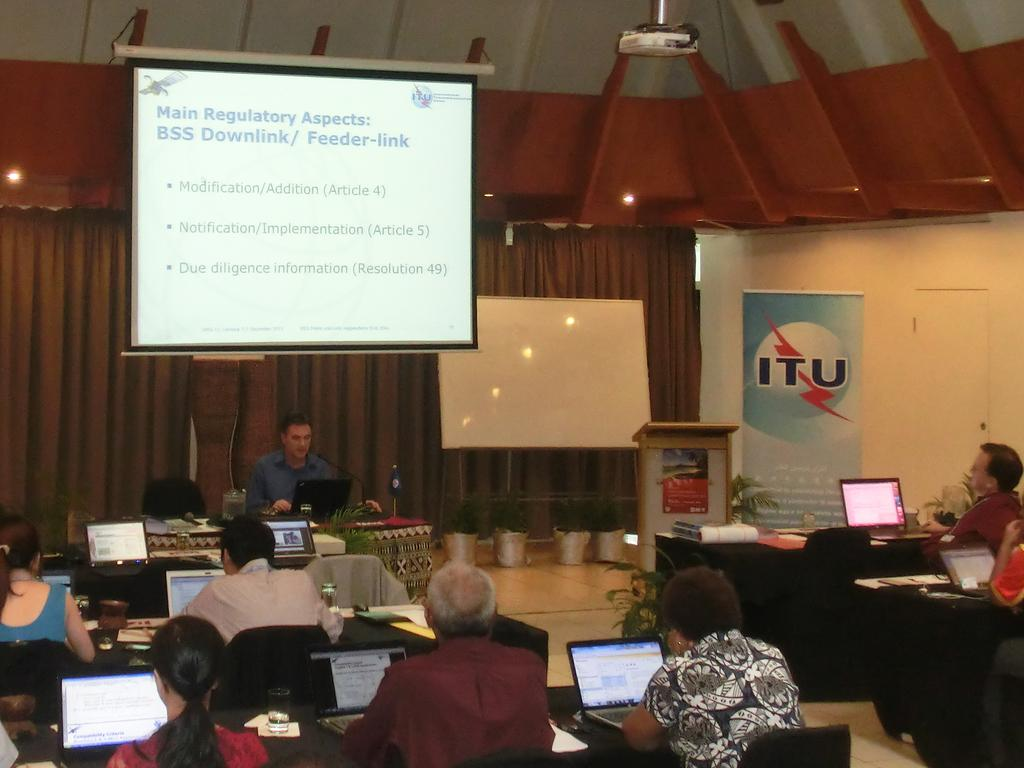<image>
Write a terse but informative summary of the picture. people with laptops at a conference with a projection screen showing main regulatory aspects at top 